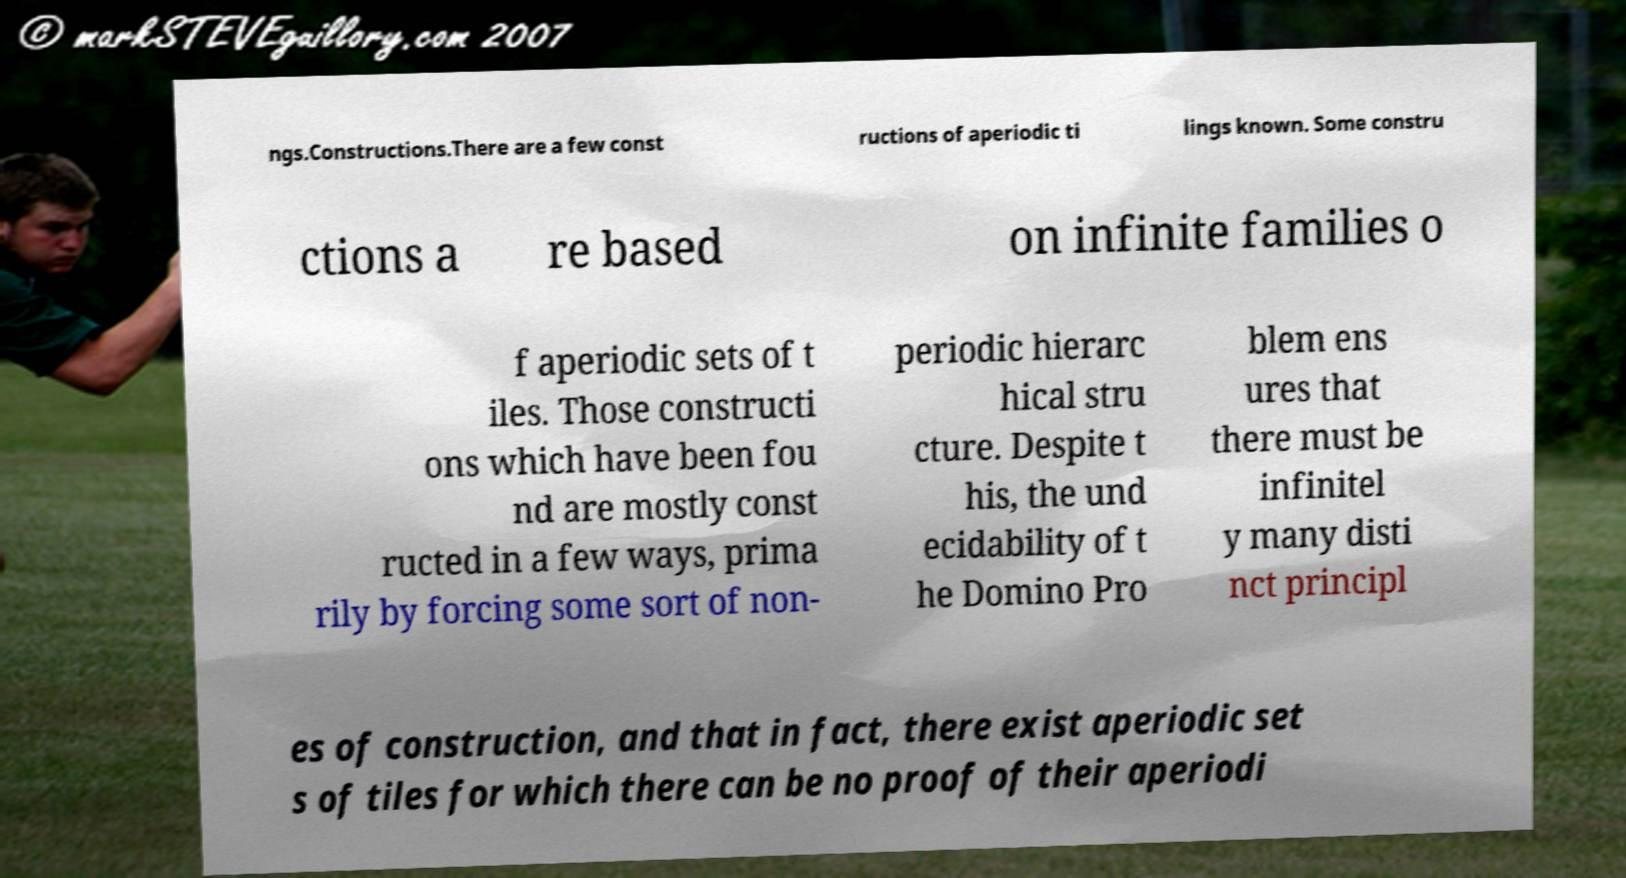Can you accurately transcribe the text from the provided image for me? ngs.Constructions.There are a few const ructions of aperiodic ti lings known. Some constru ctions a re based on infinite families o f aperiodic sets of t iles. Those constructi ons which have been fou nd are mostly const ructed in a few ways, prima rily by forcing some sort of non- periodic hierarc hical stru cture. Despite t his, the und ecidability of t he Domino Pro blem ens ures that there must be infinitel y many disti nct principl es of construction, and that in fact, there exist aperiodic set s of tiles for which there can be no proof of their aperiodi 